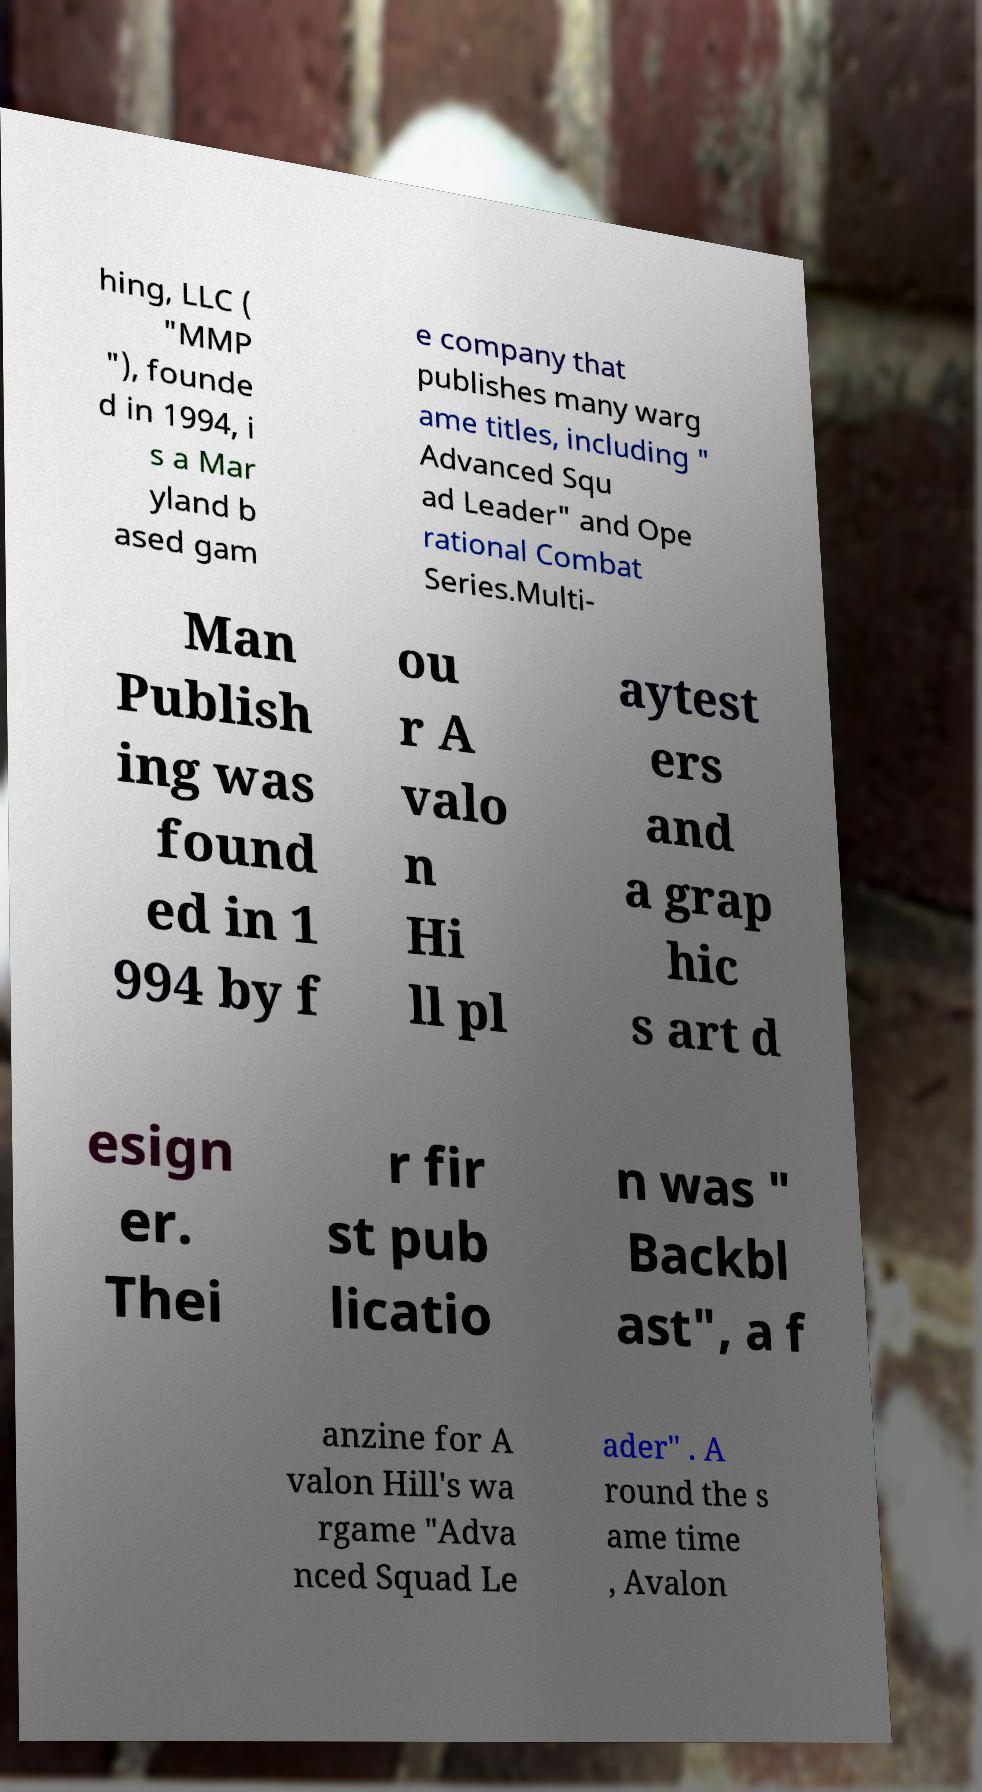Please read and relay the text visible in this image. What does it say? hing, LLC ( "MMP "), founde d in 1994, i s a Mar yland b ased gam e company that publishes many warg ame titles, including " Advanced Squ ad Leader" and Ope rational Combat Series.Multi- Man Publish ing was found ed in 1 994 by f ou r A valo n Hi ll pl aytest ers and a grap hic s art d esign er. Thei r fir st pub licatio n was " Backbl ast", a f anzine for A valon Hill's wa rgame "Adva nced Squad Le ader" . A round the s ame time , Avalon 